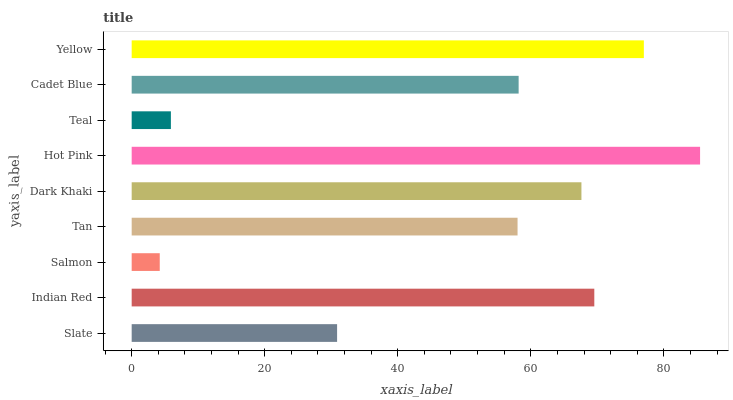Is Salmon the minimum?
Answer yes or no. Yes. Is Hot Pink the maximum?
Answer yes or no. Yes. Is Indian Red the minimum?
Answer yes or no. No. Is Indian Red the maximum?
Answer yes or no. No. Is Indian Red greater than Slate?
Answer yes or no. Yes. Is Slate less than Indian Red?
Answer yes or no. Yes. Is Slate greater than Indian Red?
Answer yes or no. No. Is Indian Red less than Slate?
Answer yes or no. No. Is Cadet Blue the high median?
Answer yes or no. Yes. Is Cadet Blue the low median?
Answer yes or no. Yes. Is Tan the high median?
Answer yes or no. No. Is Teal the low median?
Answer yes or no. No. 